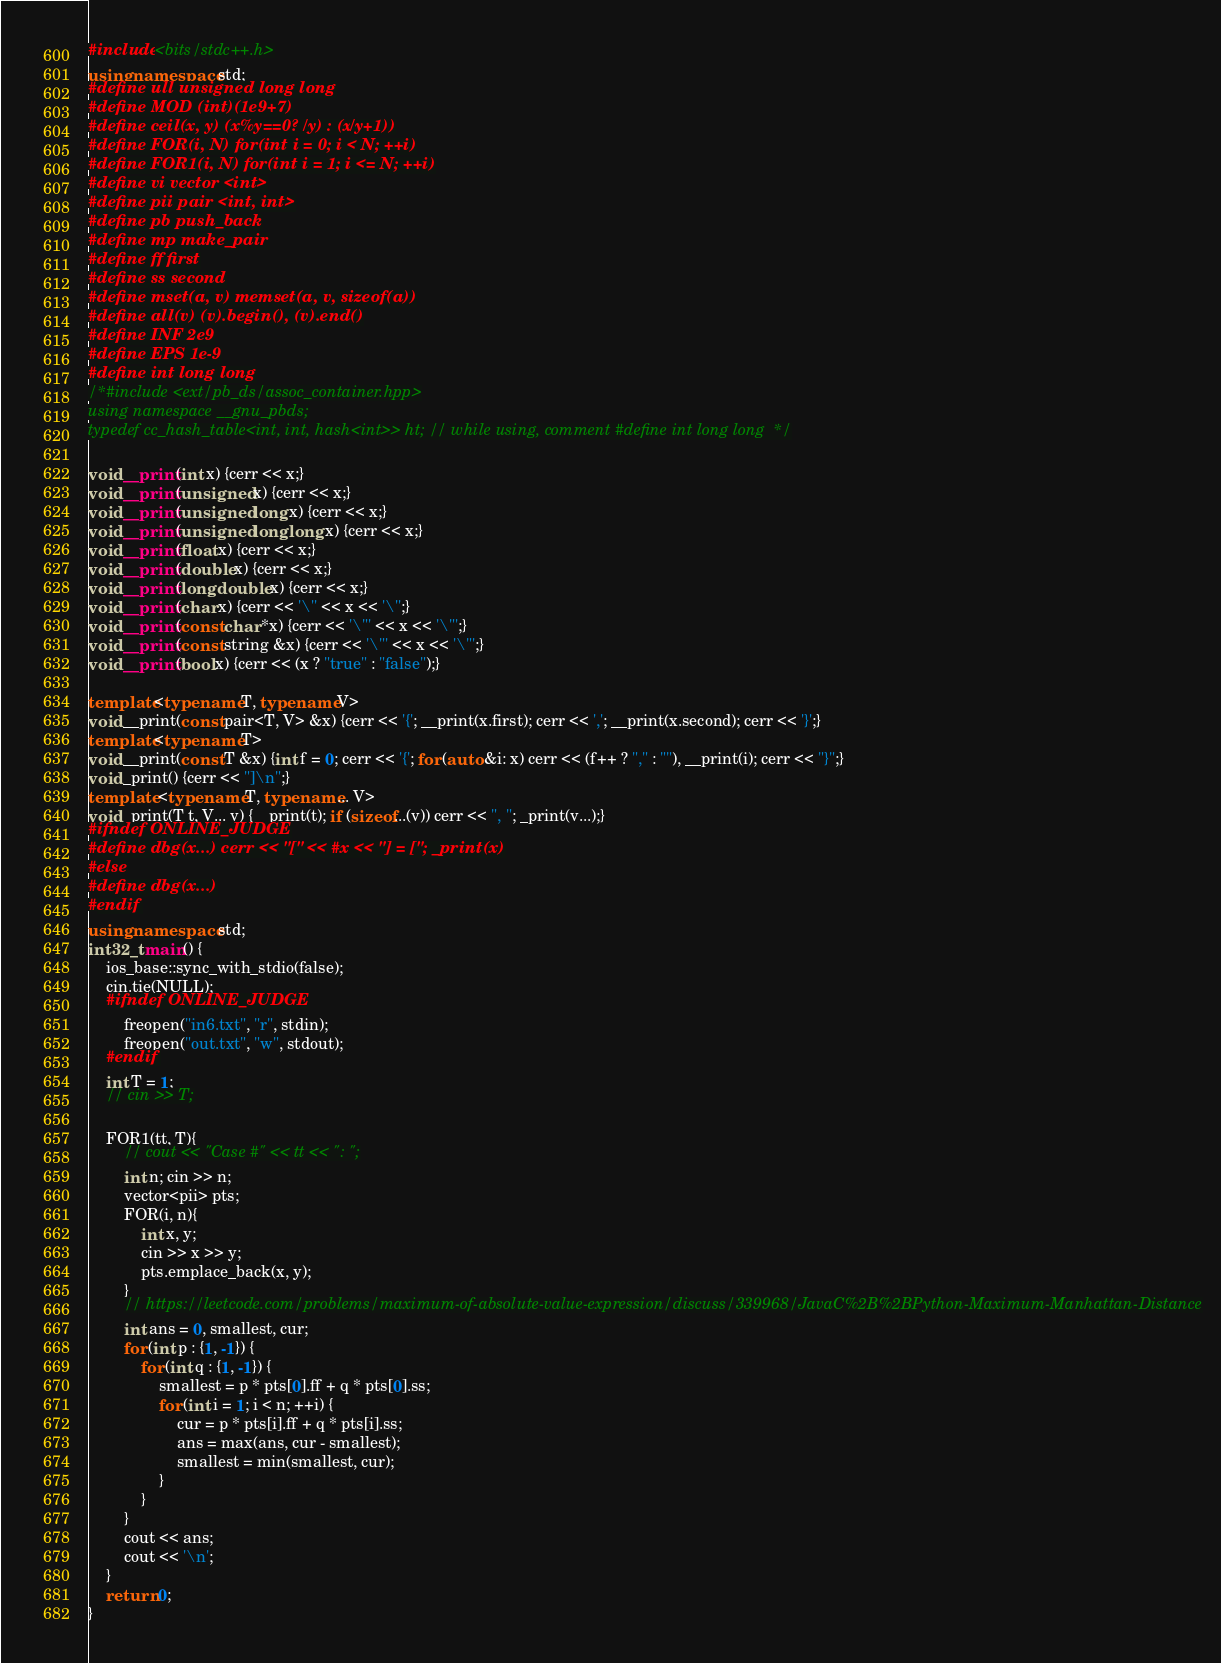Convert code to text. <code><loc_0><loc_0><loc_500><loc_500><_C++_>#include <bits/stdc++.h>
using namespace std;
#define ull unsigned long long
#define MOD (int)(1e9+7)
#define ceil(x, y) (x%y==0? (x/y) : (x/y+1))
#define FOR(i, N) for(int i = 0; i < N; ++i)
#define FOR1(i, N) for(int i = 1; i <= N; ++i)
#define vi vector <int>
#define pii pair <int, int>
#define pb push_back
#define mp make_pair
#define ff first
#define ss second
#define mset(a, v) memset(a, v, sizeof(a))
#define all(v) (v).begin(), (v).end()
#define INF 2e9
#define EPS 1e-9
#define int long long
/*#include <ext/pb_ds/assoc_container.hpp>
using namespace __gnu_pbds;
typedef cc_hash_table<int, int, hash<int>> ht; // while using, comment #define int long long  */

void __print(int x) {cerr << x;}
void __print(unsigned x) {cerr << x;}
void __print(unsigned long x) {cerr << x;}
void __print(unsigned long long x) {cerr << x;}
void __print(float x) {cerr << x;}
void __print(double x) {cerr << x;}
void __print(long double x) {cerr << x;}
void __print(char x) {cerr << '\'' << x << '\'';}
void __print(const char *x) {cerr << '\"' << x << '\"';}
void __print(const string &x) {cerr << '\"' << x << '\"';}
void __print(bool x) {cerr << (x ? "true" : "false");}

template<typename T, typename V>
void __print(const pair<T, V> &x) {cerr << '{'; __print(x.first); cerr << ','; __print(x.second); cerr << '}';}
template<typename T>
void __print(const T &x) {int f = 0; cerr << '{'; for (auto &i: x) cerr << (f++ ? "," : ""), __print(i); cerr << "}";}
void _print() {cerr << "]\n";}
template <typename T, typename... V>
void _print(T t, V... v) {__print(t); if (sizeof...(v)) cerr << ", "; _print(v...);}
#ifndef ONLINE_JUDGE
#define dbg(x...) cerr << "[" << #x << "] = ["; _print(x)
#else
#define dbg(x...)
#endif
using namespace std;
int32_t main() {
    ios_base::sync_with_stdio(false);
    cin.tie(NULL);
    #ifndef ONLINE_JUDGE
        freopen("in6.txt", "r", stdin);
        freopen("out.txt", "w", stdout);
    #endif
    int T = 1;
    // cin >> T;
    
    FOR1(tt, T){
        // cout << "Case #" << tt << ": ";
        int n; cin >> n;
        vector<pii> pts;
        FOR(i, n){
            int x, y;
            cin >> x >> y;
            pts.emplace_back(x, y);
        }
        // https://leetcode.com/problems/maximum-of-absolute-value-expression/discuss/339968/JavaC%2B%2BPython-Maximum-Manhattan-Distance
        int ans = 0, smallest, cur;
        for (int p : {1, -1}) {
            for (int q : {1, -1}) {
                smallest = p * pts[0].ff + q * pts[0].ss;
                for (int i = 1; i < n; ++i) {
                    cur = p * pts[i].ff + q * pts[i].ss;
                    ans = max(ans, cur - smallest);
                    smallest = min(smallest, cur);
                }
            }
        }
        cout << ans;
        cout << '\n';
    }
    return 0;
}
</code> 